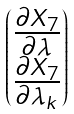Convert formula to latex. <formula><loc_0><loc_0><loc_500><loc_500>\begin{pmatrix} \frac { \partial X _ { 7 } } { \partial \lambda } \\ \frac { \partial X _ { 7 } } { \partial \lambda _ { k } } \end{pmatrix}</formula> 